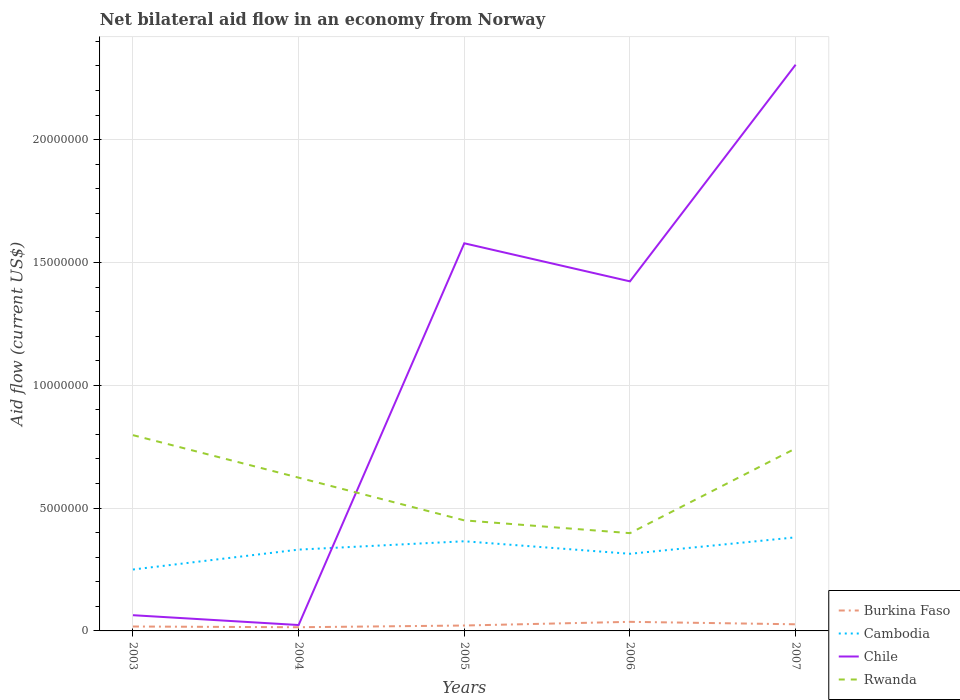How many different coloured lines are there?
Offer a terse response. 4. Across all years, what is the maximum net bilateral aid flow in Chile?
Provide a succinct answer. 2.40e+05. In which year was the net bilateral aid flow in Burkina Faso maximum?
Provide a short and direct response. 2004. What is the total net bilateral aid flow in Chile in the graph?
Keep it short and to the point. -2.24e+07. What is the difference between the highest and the second highest net bilateral aid flow in Cambodia?
Give a very brief answer. 1.31e+06. How many years are there in the graph?
Your response must be concise. 5. What is the difference between two consecutive major ticks on the Y-axis?
Offer a terse response. 5.00e+06. Are the values on the major ticks of Y-axis written in scientific E-notation?
Offer a terse response. No. Does the graph contain any zero values?
Make the answer very short. No. Does the graph contain grids?
Keep it short and to the point. Yes. Where does the legend appear in the graph?
Your answer should be compact. Bottom right. How many legend labels are there?
Keep it short and to the point. 4. What is the title of the graph?
Provide a succinct answer. Net bilateral aid flow in an economy from Norway. Does "Iceland" appear as one of the legend labels in the graph?
Keep it short and to the point. No. What is the label or title of the X-axis?
Offer a very short reply. Years. What is the Aid flow (current US$) of Burkina Faso in 2003?
Keep it short and to the point. 1.80e+05. What is the Aid flow (current US$) in Cambodia in 2003?
Keep it short and to the point. 2.50e+06. What is the Aid flow (current US$) of Chile in 2003?
Keep it short and to the point. 6.40e+05. What is the Aid flow (current US$) in Rwanda in 2003?
Your response must be concise. 7.97e+06. What is the Aid flow (current US$) of Cambodia in 2004?
Give a very brief answer. 3.31e+06. What is the Aid flow (current US$) in Rwanda in 2004?
Your answer should be very brief. 6.24e+06. What is the Aid flow (current US$) of Burkina Faso in 2005?
Provide a succinct answer. 2.20e+05. What is the Aid flow (current US$) of Cambodia in 2005?
Your response must be concise. 3.65e+06. What is the Aid flow (current US$) in Chile in 2005?
Keep it short and to the point. 1.58e+07. What is the Aid flow (current US$) in Rwanda in 2005?
Your answer should be compact. 4.50e+06. What is the Aid flow (current US$) of Cambodia in 2006?
Offer a terse response. 3.14e+06. What is the Aid flow (current US$) in Chile in 2006?
Keep it short and to the point. 1.42e+07. What is the Aid flow (current US$) in Rwanda in 2006?
Your answer should be compact. 3.98e+06. What is the Aid flow (current US$) in Cambodia in 2007?
Your answer should be very brief. 3.81e+06. What is the Aid flow (current US$) of Chile in 2007?
Offer a terse response. 2.30e+07. What is the Aid flow (current US$) in Rwanda in 2007?
Your answer should be very brief. 7.43e+06. Across all years, what is the maximum Aid flow (current US$) in Burkina Faso?
Offer a terse response. 3.70e+05. Across all years, what is the maximum Aid flow (current US$) of Cambodia?
Provide a succinct answer. 3.81e+06. Across all years, what is the maximum Aid flow (current US$) of Chile?
Provide a short and direct response. 2.30e+07. Across all years, what is the maximum Aid flow (current US$) in Rwanda?
Make the answer very short. 7.97e+06. Across all years, what is the minimum Aid flow (current US$) of Cambodia?
Give a very brief answer. 2.50e+06. Across all years, what is the minimum Aid flow (current US$) in Rwanda?
Keep it short and to the point. 3.98e+06. What is the total Aid flow (current US$) in Burkina Faso in the graph?
Your answer should be compact. 1.19e+06. What is the total Aid flow (current US$) in Cambodia in the graph?
Give a very brief answer. 1.64e+07. What is the total Aid flow (current US$) of Chile in the graph?
Provide a short and direct response. 5.39e+07. What is the total Aid flow (current US$) in Rwanda in the graph?
Give a very brief answer. 3.01e+07. What is the difference between the Aid flow (current US$) of Burkina Faso in 2003 and that in 2004?
Ensure brevity in your answer.  3.00e+04. What is the difference between the Aid flow (current US$) of Cambodia in 2003 and that in 2004?
Your answer should be compact. -8.10e+05. What is the difference between the Aid flow (current US$) of Rwanda in 2003 and that in 2004?
Give a very brief answer. 1.73e+06. What is the difference between the Aid flow (current US$) in Cambodia in 2003 and that in 2005?
Your answer should be very brief. -1.15e+06. What is the difference between the Aid flow (current US$) in Chile in 2003 and that in 2005?
Provide a succinct answer. -1.51e+07. What is the difference between the Aid flow (current US$) in Rwanda in 2003 and that in 2005?
Give a very brief answer. 3.47e+06. What is the difference between the Aid flow (current US$) in Cambodia in 2003 and that in 2006?
Make the answer very short. -6.40e+05. What is the difference between the Aid flow (current US$) of Chile in 2003 and that in 2006?
Ensure brevity in your answer.  -1.36e+07. What is the difference between the Aid flow (current US$) in Rwanda in 2003 and that in 2006?
Offer a terse response. 3.99e+06. What is the difference between the Aid flow (current US$) of Cambodia in 2003 and that in 2007?
Make the answer very short. -1.31e+06. What is the difference between the Aid flow (current US$) of Chile in 2003 and that in 2007?
Keep it short and to the point. -2.24e+07. What is the difference between the Aid flow (current US$) of Rwanda in 2003 and that in 2007?
Keep it short and to the point. 5.40e+05. What is the difference between the Aid flow (current US$) in Cambodia in 2004 and that in 2005?
Ensure brevity in your answer.  -3.40e+05. What is the difference between the Aid flow (current US$) of Chile in 2004 and that in 2005?
Offer a terse response. -1.55e+07. What is the difference between the Aid flow (current US$) of Rwanda in 2004 and that in 2005?
Your response must be concise. 1.74e+06. What is the difference between the Aid flow (current US$) in Chile in 2004 and that in 2006?
Your response must be concise. -1.40e+07. What is the difference between the Aid flow (current US$) of Rwanda in 2004 and that in 2006?
Keep it short and to the point. 2.26e+06. What is the difference between the Aid flow (current US$) of Burkina Faso in 2004 and that in 2007?
Offer a very short reply. -1.20e+05. What is the difference between the Aid flow (current US$) in Cambodia in 2004 and that in 2007?
Give a very brief answer. -5.00e+05. What is the difference between the Aid flow (current US$) of Chile in 2004 and that in 2007?
Your answer should be compact. -2.28e+07. What is the difference between the Aid flow (current US$) of Rwanda in 2004 and that in 2007?
Make the answer very short. -1.19e+06. What is the difference between the Aid flow (current US$) in Cambodia in 2005 and that in 2006?
Your answer should be very brief. 5.10e+05. What is the difference between the Aid flow (current US$) in Chile in 2005 and that in 2006?
Offer a terse response. 1.55e+06. What is the difference between the Aid flow (current US$) of Rwanda in 2005 and that in 2006?
Your answer should be very brief. 5.20e+05. What is the difference between the Aid flow (current US$) in Burkina Faso in 2005 and that in 2007?
Offer a very short reply. -5.00e+04. What is the difference between the Aid flow (current US$) of Chile in 2005 and that in 2007?
Make the answer very short. -7.27e+06. What is the difference between the Aid flow (current US$) of Rwanda in 2005 and that in 2007?
Provide a short and direct response. -2.93e+06. What is the difference between the Aid flow (current US$) of Cambodia in 2006 and that in 2007?
Ensure brevity in your answer.  -6.70e+05. What is the difference between the Aid flow (current US$) of Chile in 2006 and that in 2007?
Provide a short and direct response. -8.82e+06. What is the difference between the Aid flow (current US$) in Rwanda in 2006 and that in 2007?
Offer a very short reply. -3.45e+06. What is the difference between the Aid flow (current US$) in Burkina Faso in 2003 and the Aid flow (current US$) in Cambodia in 2004?
Your response must be concise. -3.13e+06. What is the difference between the Aid flow (current US$) in Burkina Faso in 2003 and the Aid flow (current US$) in Rwanda in 2004?
Provide a succinct answer. -6.06e+06. What is the difference between the Aid flow (current US$) in Cambodia in 2003 and the Aid flow (current US$) in Chile in 2004?
Keep it short and to the point. 2.26e+06. What is the difference between the Aid flow (current US$) in Cambodia in 2003 and the Aid flow (current US$) in Rwanda in 2004?
Keep it short and to the point. -3.74e+06. What is the difference between the Aid flow (current US$) in Chile in 2003 and the Aid flow (current US$) in Rwanda in 2004?
Offer a very short reply. -5.60e+06. What is the difference between the Aid flow (current US$) in Burkina Faso in 2003 and the Aid flow (current US$) in Cambodia in 2005?
Offer a terse response. -3.47e+06. What is the difference between the Aid flow (current US$) of Burkina Faso in 2003 and the Aid flow (current US$) of Chile in 2005?
Give a very brief answer. -1.56e+07. What is the difference between the Aid flow (current US$) of Burkina Faso in 2003 and the Aid flow (current US$) of Rwanda in 2005?
Your answer should be very brief. -4.32e+06. What is the difference between the Aid flow (current US$) in Cambodia in 2003 and the Aid flow (current US$) in Chile in 2005?
Make the answer very short. -1.33e+07. What is the difference between the Aid flow (current US$) in Chile in 2003 and the Aid flow (current US$) in Rwanda in 2005?
Your answer should be compact. -3.86e+06. What is the difference between the Aid flow (current US$) of Burkina Faso in 2003 and the Aid flow (current US$) of Cambodia in 2006?
Offer a very short reply. -2.96e+06. What is the difference between the Aid flow (current US$) of Burkina Faso in 2003 and the Aid flow (current US$) of Chile in 2006?
Provide a succinct answer. -1.40e+07. What is the difference between the Aid flow (current US$) of Burkina Faso in 2003 and the Aid flow (current US$) of Rwanda in 2006?
Offer a terse response. -3.80e+06. What is the difference between the Aid flow (current US$) of Cambodia in 2003 and the Aid flow (current US$) of Chile in 2006?
Your answer should be very brief. -1.17e+07. What is the difference between the Aid flow (current US$) in Cambodia in 2003 and the Aid flow (current US$) in Rwanda in 2006?
Give a very brief answer. -1.48e+06. What is the difference between the Aid flow (current US$) in Chile in 2003 and the Aid flow (current US$) in Rwanda in 2006?
Make the answer very short. -3.34e+06. What is the difference between the Aid flow (current US$) of Burkina Faso in 2003 and the Aid flow (current US$) of Cambodia in 2007?
Provide a short and direct response. -3.63e+06. What is the difference between the Aid flow (current US$) of Burkina Faso in 2003 and the Aid flow (current US$) of Chile in 2007?
Your answer should be compact. -2.29e+07. What is the difference between the Aid flow (current US$) of Burkina Faso in 2003 and the Aid flow (current US$) of Rwanda in 2007?
Offer a terse response. -7.25e+06. What is the difference between the Aid flow (current US$) of Cambodia in 2003 and the Aid flow (current US$) of Chile in 2007?
Give a very brief answer. -2.06e+07. What is the difference between the Aid flow (current US$) in Cambodia in 2003 and the Aid flow (current US$) in Rwanda in 2007?
Offer a terse response. -4.93e+06. What is the difference between the Aid flow (current US$) in Chile in 2003 and the Aid flow (current US$) in Rwanda in 2007?
Keep it short and to the point. -6.79e+06. What is the difference between the Aid flow (current US$) in Burkina Faso in 2004 and the Aid flow (current US$) in Cambodia in 2005?
Give a very brief answer. -3.50e+06. What is the difference between the Aid flow (current US$) in Burkina Faso in 2004 and the Aid flow (current US$) in Chile in 2005?
Ensure brevity in your answer.  -1.56e+07. What is the difference between the Aid flow (current US$) of Burkina Faso in 2004 and the Aid flow (current US$) of Rwanda in 2005?
Give a very brief answer. -4.35e+06. What is the difference between the Aid flow (current US$) of Cambodia in 2004 and the Aid flow (current US$) of Chile in 2005?
Your answer should be very brief. -1.25e+07. What is the difference between the Aid flow (current US$) in Cambodia in 2004 and the Aid flow (current US$) in Rwanda in 2005?
Keep it short and to the point. -1.19e+06. What is the difference between the Aid flow (current US$) of Chile in 2004 and the Aid flow (current US$) of Rwanda in 2005?
Offer a very short reply. -4.26e+06. What is the difference between the Aid flow (current US$) in Burkina Faso in 2004 and the Aid flow (current US$) in Cambodia in 2006?
Make the answer very short. -2.99e+06. What is the difference between the Aid flow (current US$) in Burkina Faso in 2004 and the Aid flow (current US$) in Chile in 2006?
Offer a terse response. -1.41e+07. What is the difference between the Aid flow (current US$) of Burkina Faso in 2004 and the Aid flow (current US$) of Rwanda in 2006?
Make the answer very short. -3.83e+06. What is the difference between the Aid flow (current US$) of Cambodia in 2004 and the Aid flow (current US$) of Chile in 2006?
Your response must be concise. -1.09e+07. What is the difference between the Aid flow (current US$) in Cambodia in 2004 and the Aid flow (current US$) in Rwanda in 2006?
Provide a short and direct response. -6.70e+05. What is the difference between the Aid flow (current US$) in Chile in 2004 and the Aid flow (current US$) in Rwanda in 2006?
Your response must be concise. -3.74e+06. What is the difference between the Aid flow (current US$) of Burkina Faso in 2004 and the Aid flow (current US$) of Cambodia in 2007?
Keep it short and to the point. -3.66e+06. What is the difference between the Aid flow (current US$) of Burkina Faso in 2004 and the Aid flow (current US$) of Chile in 2007?
Keep it short and to the point. -2.29e+07. What is the difference between the Aid flow (current US$) of Burkina Faso in 2004 and the Aid flow (current US$) of Rwanda in 2007?
Ensure brevity in your answer.  -7.28e+06. What is the difference between the Aid flow (current US$) of Cambodia in 2004 and the Aid flow (current US$) of Chile in 2007?
Provide a short and direct response. -1.97e+07. What is the difference between the Aid flow (current US$) of Cambodia in 2004 and the Aid flow (current US$) of Rwanda in 2007?
Offer a very short reply. -4.12e+06. What is the difference between the Aid flow (current US$) of Chile in 2004 and the Aid flow (current US$) of Rwanda in 2007?
Give a very brief answer. -7.19e+06. What is the difference between the Aid flow (current US$) in Burkina Faso in 2005 and the Aid flow (current US$) in Cambodia in 2006?
Your answer should be compact. -2.92e+06. What is the difference between the Aid flow (current US$) in Burkina Faso in 2005 and the Aid flow (current US$) in Chile in 2006?
Provide a short and direct response. -1.40e+07. What is the difference between the Aid flow (current US$) of Burkina Faso in 2005 and the Aid flow (current US$) of Rwanda in 2006?
Give a very brief answer. -3.76e+06. What is the difference between the Aid flow (current US$) in Cambodia in 2005 and the Aid flow (current US$) in Chile in 2006?
Offer a very short reply. -1.06e+07. What is the difference between the Aid flow (current US$) in Cambodia in 2005 and the Aid flow (current US$) in Rwanda in 2006?
Make the answer very short. -3.30e+05. What is the difference between the Aid flow (current US$) of Chile in 2005 and the Aid flow (current US$) of Rwanda in 2006?
Ensure brevity in your answer.  1.18e+07. What is the difference between the Aid flow (current US$) in Burkina Faso in 2005 and the Aid flow (current US$) in Cambodia in 2007?
Offer a terse response. -3.59e+06. What is the difference between the Aid flow (current US$) in Burkina Faso in 2005 and the Aid flow (current US$) in Chile in 2007?
Your answer should be compact. -2.28e+07. What is the difference between the Aid flow (current US$) in Burkina Faso in 2005 and the Aid flow (current US$) in Rwanda in 2007?
Keep it short and to the point. -7.21e+06. What is the difference between the Aid flow (current US$) in Cambodia in 2005 and the Aid flow (current US$) in Chile in 2007?
Provide a succinct answer. -1.94e+07. What is the difference between the Aid flow (current US$) in Cambodia in 2005 and the Aid flow (current US$) in Rwanda in 2007?
Give a very brief answer. -3.78e+06. What is the difference between the Aid flow (current US$) of Chile in 2005 and the Aid flow (current US$) of Rwanda in 2007?
Give a very brief answer. 8.35e+06. What is the difference between the Aid flow (current US$) of Burkina Faso in 2006 and the Aid flow (current US$) of Cambodia in 2007?
Provide a short and direct response. -3.44e+06. What is the difference between the Aid flow (current US$) of Burkina Faso in 2006 and the Aid flow (current US$) of Chile in 2007?
Your answer should be compact. -2.27e+07. What is the difference between the Aid flow (current US$) in Burkina Faso in 2006 and the Aid flow (current US$) in Rwanda in 2007?
Provide a succinct answer. -7.06e+06. What is the difference between the Aid flow (current US$) of Cambodia in 2006 and the Aid flow (current US$) of Chile in 2007?
Keep it short and to the point. -1.99e+07. What is the difference between the Aid flow (current US$) of Cambodia in 2006 and the Aid flow (current US$) of Rwanda in 2007?
Your response must be concise. -4.29e+06. What is the difference between the Aid flow (current US$) of Chile in 2006 and the Aid flow (current US$) of Rwanda in 2007?
Ensure brevity in your answer.  6.80e+06. What is the average Aid flow (current US$) of Burkina Faso per year?
Give a very brief answer. 2.38e+05. What is the average Aid flow (current US$) in Cambodia per year?
Your response must be concise. 3.28e+06. What is the average Aid flow (current US$) of Chile per year?
Your answer should be compact. 1.08e+07. What is the average Aid flow (current US$) in Rwanda per year?
Make the answer very short. 6.02e+06. In the year 2003, what is the difference between the Aid flow (current US$) in Burkina Faso and Aid flow (current US$) in Cambodia?
Provide a short and direct response. -2.32e+06. In the year 2003, what is the difference between the Aid flow (current US$) in Burkina Faso and Aid flow (current US$) in Chile?
Keep it short and to the point. -4.60e+05. In the year 2003, what is the difference between the Aid flow (current US$) in Burkina Faso and Aid flow (current US$) in Rwanda?
Your answer should be compact. -7.79e+06. In the year 2003, what is the difference between the Aid flow (current US$) in Cambodia and Aid flow (current US$) in Chile?
Keep it short and to the point. 1.86e+06. In the year 2003, what is the difference between the Aid flow (current US$) in Cambodia and Aid flow (current US$) in Rwanda?
Your response must be concise. -5.47e+06. In the year 2003, what is the difference between the Aid flow (current US$) of Chile and Aid flow (current US$) of Rwanda?
Keep it short and to the point. -7.33e+06. In the year 2004, what is the difference between the Aid flow (current US$) of Burkina Faso and Aid flow (current US$) of Cambodia?
Give a very brief answer. -3.16e+06. In the year 2004, what is the difference between the Aid flow (current US$) of Burkina Faso and Aid flow (current US$) of Rwanda?
Provide a succinct answer. -6.09e+06. In the year 2004, what is the difference between the Aid flow (current US$) of Cambodia and Aid flow (current US$) of Chile?
Your answer should be very brief. 3.07e+06. In the year 2004, what is the difference between the Aid flow (current US$) in Cambodia and Aid flow (current US$) in Rwanda?
Provide a succinct answer. -2.93e+06. In the year 2004, what is the difference between the Aid flow (current US$) of Chile and Aid flow (current US$) of Rwanda?
Keep it short and to the point. -6.00e+06. In the year 2005, what is the difference between the Aid flow (current US$) in Burkina Faso and Aid flow (current US$) in Cambodia?
Your answer should be very brief. -3.43e+06. In the year 2005, what is the difference between the Aid flow (current US$) of Burkina Faso and Aid flow (current US$) of Chile?
Offer a terse response. -1.56e+07. In the year 2005, what is the difference between the Aid flow (current US$) in Burkina Faso and Aid flow (current US$) in Rwanda?
Your answer should be very brief. -4.28e+06. In the year 2005, what is the difference between the Aid flow (current US$) of Cambodia and Aid flow (current US$) of Chile?
Your answer should be compact. -1.21e+07. In the year 2005, what is the difference between the Aid flow (current US$) in Cambodia and Aid flow (current US$) in Rwanda?
Offer a terse response. -8.50e+05. In the year 2005, what is the difference between the Aid flow (current US$) in Chile and Aid flow (current US$) in Rwanda?
Provide a short and direct response. 1.13e+07. In the year 2006, what is the difference between the Aid flow (current US$) of Burkina Faso and Aid flow (current US$) of Cambodia?
Provide a short and direct response. -2.77e+06. In the year 2006, what is the difference between the Aid flow (current US$) of Burkina Faso and Aid flow (current US$) of Chile?
Offer a very short reply. -1.39e+07. In the year 2006, what is the difference between the Aid flow (current US$) of Burkina Faso and Aid flow (current US$) of Rwanda?
Keep it short and to the point. -3.61e+06. In the year 2006, what is the difference between the Aid flow (current US$) in Cambodia and Aid flow (current US$) in Chile?
Give a very brief answer. -1.11e+07. In the year 2006, what is the difference between the Aid flow (current US$) in Cambodia and Aid flow (current US$) in Rwanda?
Provide a short and direct response. -8.40e+05. In the year 2006, what is the difference between the Aid flow (current US$) in Chile and Aid flow (current US$) in Rwanda?
Offer a terse response. 1.02e+07. In the year 2007, what is the difference between the Aid flow (current US$) in Burkina Faso and Aid flow (current US$) in Cambodia?
Offer a very short reply. -3.54e+06. In the year 2007, what is the difference between the Aid flow (current US$) of Burkina Faso and Aid flow (current US$) of Chile?
Provide a succinct answer. -2.28e+07. In the year 2007, what is the difference between the Aid flow (current US$) of Burkina Faso and Aid flow (current US$) of Rwanda?
Provide a short and direct response. -7.16e+06. In the year 2007, what is the difference between the Aid flow (current US$) in Cambodia and Aid flow (current US$) in Chile?
Give a very brief answer. -1.92e+07. In the year 2007, what is the difference between the Aid flow (current US$) in Cambodia and Aid flow (current US$) in Rwanda?
Offer a terse response. -3.62e+06. In the year 2007, what is the difference between the Aid flow (current US$) of Chile and Aid flow (current US$) of Rwanda?
Keep it short and to the point. 1.56e+07. What is the ratio of the Aid flow (current US$) of Burkina Faso in 2003 to that in 2004?
Ensure brevity in your answer.  1.2. What is the ratio of the Aid flow (current US$) of Cambodia in 2003 to that in 2004?
Ensure brevity in your answer.  0.76. What is the ratio of the Aid flow (current US$) in Chile in 2003 to that in 2004?
Your answer should be compact. 2.67. What is the ratio of the Aid flow (current US$) in Rwanda in 2003 to that in 2004?
Your response must be concise. 1.28. What is the ratio of the Aid flow (current US$) of Burkina Faso in 2003 to that in 2005?
Your answer should be compact. 0.82. What is the ratio of the Aid flow (current US$) in Cambodia in 2003 to that in 2005?
Offer a very short reply. 0.68. What is the ratio of the Aid flow (current US$) in Chile in 2003 to that in 2005?
Offer a terse response. 0.04. What is the ratio of the Aid flow (current US$) of Rwanda in 2003 to that in 2005?
Your response must be concise. 1.77. What is the ratio of the Aid flow (current US$) of Burkina Faso in 2003 to that in 2006?
Offer a terse response. 0.49. What is the ratio of the Aid flow (current US$) of Cambodia in 2003 to that in 2006?
Provide a short and direct response. 0.8. What is the ratio of the Aid flow (current US$) in Chile in 2003 to that in 2006?
Keep it short and to the point. 0.04. What is the ratio of the Aid flow (current US$) in Rwanda in 2003 to that in 2006?
Your answer should be very brief. 2. What is the ratio of the Aid flow (current US$) of Cambodia in 2003 to that in 2007?
Give a very brief answer. 0.66. What is the ratio of the Aid flow (current US$) in Chile in 2003 to that in 2007?
Offer a terse response. 0.03. What is the ratio of the Aid flow (current US$) in Rwanda in 2003 to that in 2007?
Make the answer very short. 1.07. What is the ratio of the Aid flow (current US$) of Burkina Faso in 2004 to that in 2005?
Provide a short and direct response. 0.68. What is the ratio of the Aid flow (current US$) of Cambodia in 2004 to that in 2005?
Give a very brief answer. 0.91. What is the ratio of the Aid flow (current US$) of Chile in 2004 to that in 2005?
Give a very brief answer. 0.02. What is the ratio of the Aid flow (current US$) of Rwanda in 2004 to that in 2005?
Ensure brevity in your answer.  1.39. What is the ratio of the Aid flow (current US$) in Burkina Faso in 2004 to that in 2006?
Your response must be concise. 0.41. What is the ratio of the Aid flow (current US$) in Cambodia in 2004 to that in 2006?
Your response must be concise. 1.05. What is the ratio of the Aid flow (current US$) in Chile in 2004 to that in 2006?
Your response must be concise. 0.02. What is the ratio of the Aid flow (current US$) in Rwanda in 2004 to that in 2006?
Your answer should be compact. 1.57. What is the ratio of the Aid flow (current US$) in Burkina Faso in 2004 to that in 2007?
Keep it short and to the point. 0.56. What is the ratio of the Aid flow (current US$) of Cambodia in 2004 to that in 2007?
Provide a short and direct response. 0.87. What is the ratio of the Aid flow (current US$) of Chile in 2004 to that in 2007?
Your response must be concise. 0.01. What is the ratio of the Aid flow (current US$) of Rwanda in 2004 to that in 2007?
Provide a short and direct response. 0.84. What is the ratio of the Aid flow (current US$) of Burkina Faso in 2005 to that in 2006?
Make the answer very short. 0.59. What is the ratio of the Aid flow (current US$) in Cambodia in 2005 to that in 2006?
Ensure brevity in your answer.  1.16. What is the ratio of the Aid flow (current US$) in Chile in 2005 to that in 2006?
Keep it short and to the point. 1.11. What is the ratio of the Aid flow (current US$) in Rwanda in 2005 to that in 2006?
Your answer should be very brief. 1.13. What is the ratio of the Aid flow (current US$) in Burkina Faso in 2005 to that in 2007?
Keep it short and to the point. 0.81. What is the ratio of the Aid flow (current US$) in Cambodia in 2005 to that in 2007?
Provide a succinct answer. 0.96. What is the ratio of the Aid flow (current US$) of Chile in 2005 to that in 2007?
Ensure brevity in your answer.  0.68. What is the ratio of the Aid flow (current US$) in Rwanda in 2005 to that in 2007?
Your response must be concise. 0.61. What is the ratio of the Aid flow (current US$) in Burkina Faso in 2006 to that in 2007?
Your response must be concise. 1.37. What is the ratio of the Aid flow (current US$) of Cambodia in 2006 to that in 2007?
Provide a short and direct response. 0.82. What is the ratio of the Aid flow (current US$) in Chile in 2006 to that in 2007?
Make the answer very short. 0.62. What is the ratio of the Aid flow (current US$) in Rwanda in 2006 to that in 2007?
Give a very brief answer. 0.54. What is the difference between the highest and the second highest Aid flow (current US$) of Burkina Faso?
Provide a succinct answer. 1.00e+05. What is the difference between the highest and the second highest Aid flow (current US$) of Chile?
Give a very brief answer. 7.27e+06. What is the difference between the highest and the second highest Aid flow (current US$) of Rwanda?
Make the answer very short. 5.40e+05. What is the difference between the highest and the lowest Aid flow (current US$) of Burkina Faso?
Provide a succinct answer. 2.20e+05. What is the difference between the highest and the lowest Aid flow (current US$) in Cambodia?
Give a very brief answer. 1.31e+06. What is the difference between the highest and the lowest Aid flow (current US$) of Chile?
Make the answer very short. 2.28e+07. What is the difference between the highest and the lowest Aid flow (current US$) in Rwanda?
Offer a terse response. 3.99e+06. 